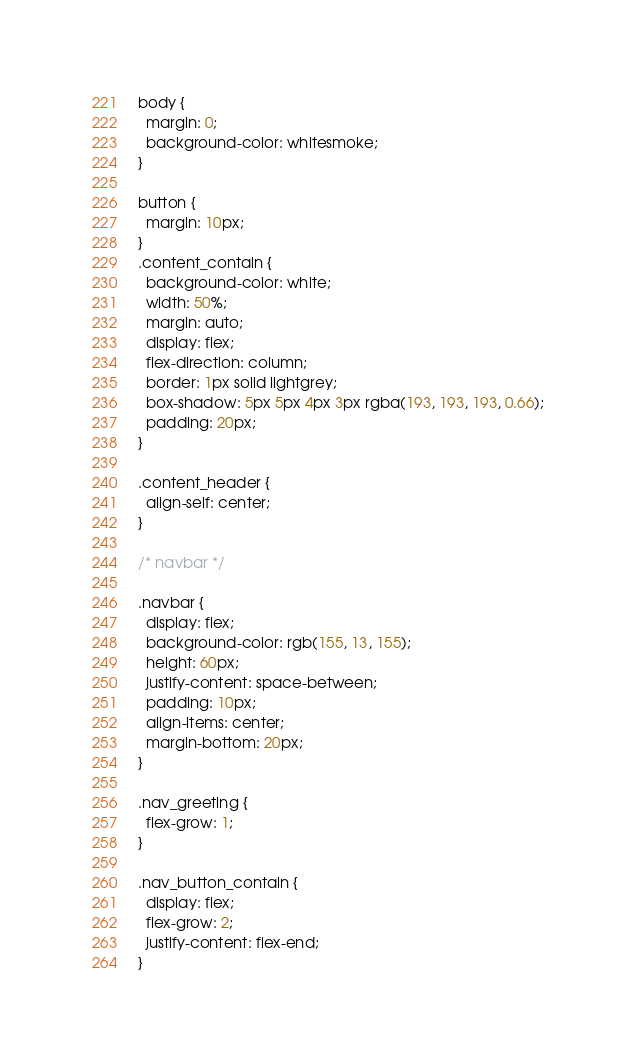<code> <loc_0><loc_0><loc_500><loc_500><_CSS_>body {
  margin: 0;
  background-color: whitesmoke;
}

button {
  margin: 10px;
}
.content_contain {
  background-color: white;
  width: 50%;
  margin: auto;
  display: flex;
  flex-direction: column;
  border: 1px solid lightgrey;
  box-shadow: 5px 5px 4px 3px rgba(193, 193, 193, 0.66);
  padding: 20px;
}

.content_header {
  align-self: center;
}

/* navbar */

.navbar {
  display: flex;
  background-color: rgb(155, 13, 155);
  height: 60px;
  justify-content: space-between;
  padding: 10px;
  align-items: center;
  margin-bottom: 20px;
}

.nav_greeting {
  flex-grow: 1;
}

.nav_button_contain {
  display: flex;
  flex-grow: 2;
  justify-content: flex-end;
}
</code> 